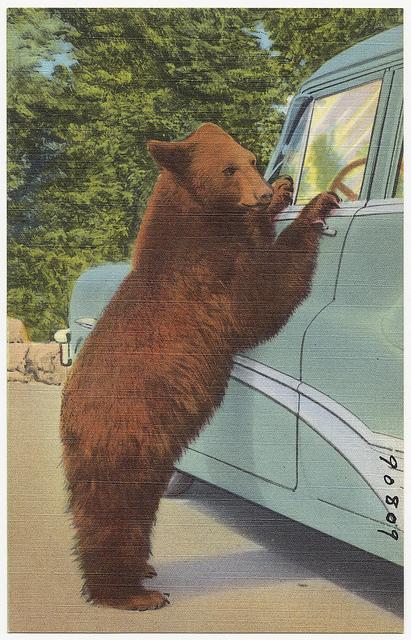Is the bear going to drive the car?
Write a very short answer. No. What damage could the bear do to the car?
Give a very brief answer. Break window. Is this photo real?
Short answer required. No. How many bears are there?
Concise answer only. 1. 